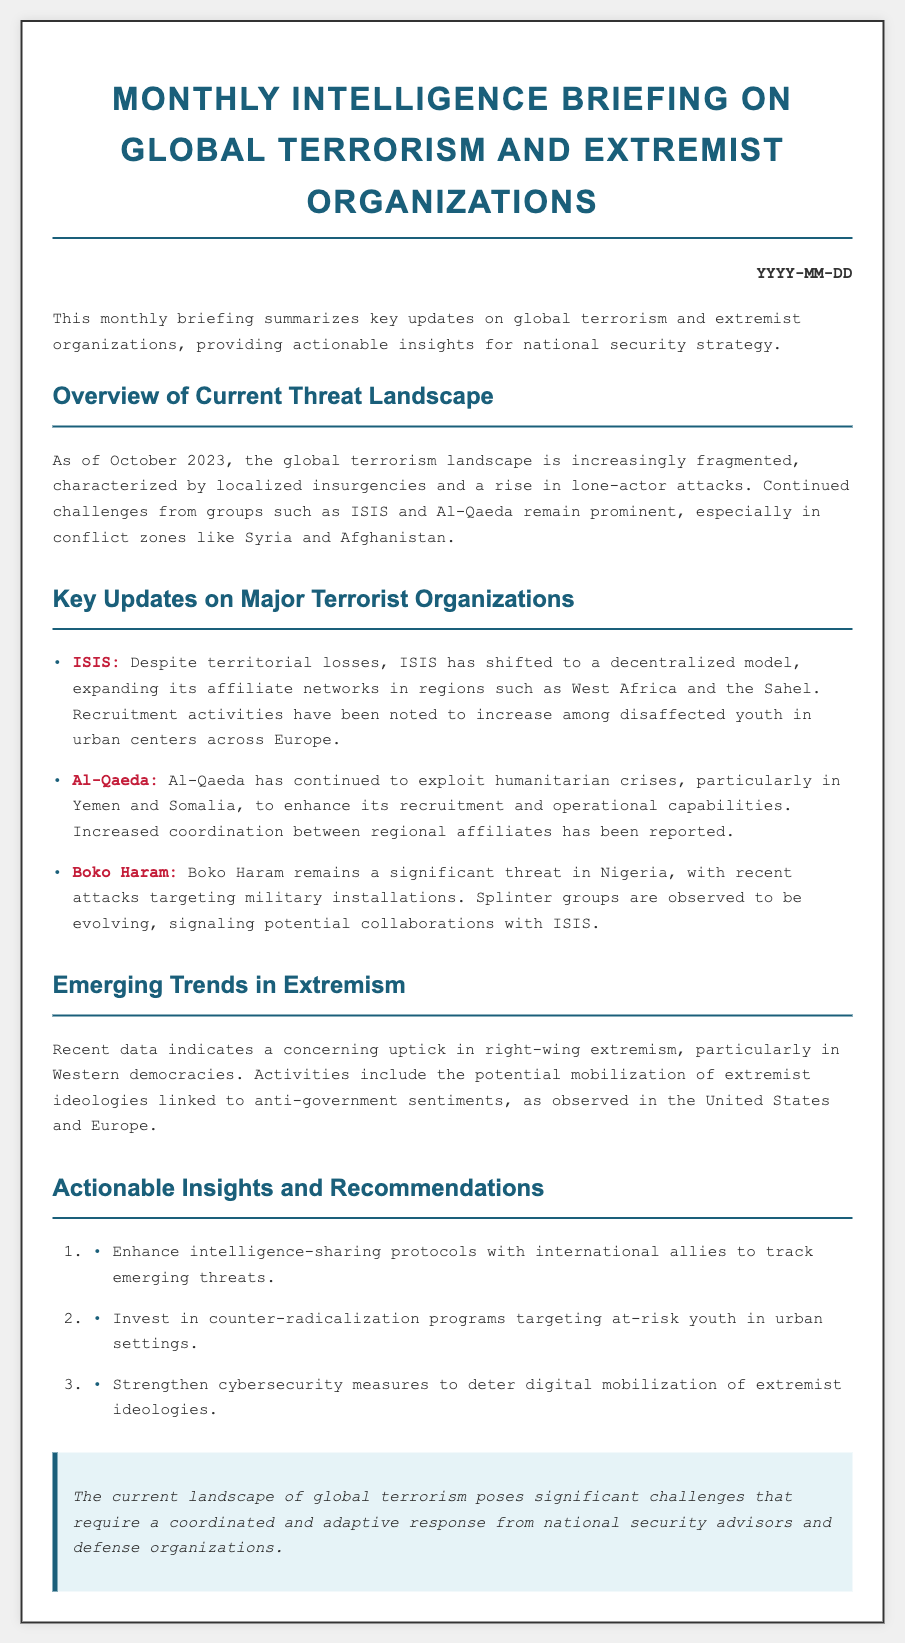What is the date of the briefing? The date is located at the top right of the briefing, formatted as YYYY-MM-DD, which needs to be filled in according to the current month.
Answer: YYYY-MM-DD Which organization has shifted to a decentralized model? The briefing mentions that ISIS has implemented a decentralized model despite its territorial losses.
Answer: ISIS What region is experiencing an increase in ISIS recruitment? The document specifies urban centers across Europe as regions where ISIS recruitment activities are increasing.
Answer: Europe What is a significant emerging trend mentioned in the briefing? The briefing highlights a concerning uptick in right-wing extremism, particularly in Western democracies.
Answer: Right-wing extremism What recommendation involves international cooperation? The document advises enhancing intelligence-sharing protocols with international allies to track emerging threats.
Answer: Intelligence-sharing protocols Which two countries are mentioned in relation to Al-Qaeda's exploitation of humanitarian crises? The briefing identifies Yemen and Somalia as key areas where Al-Qaeda is exploiting humanitarian crises.
Answer: Yemen and Somalia What type of extremist ideologies have seen increased activity in the United States? The document states that there is potential mobilization of extremist ideologies linked to anti-government sentiments in the United States.
Answer: Anti-government sentiments How many actionable insights are provided in the document? The document contains a list of three actionable insights and recommendations.
Answer: Three 